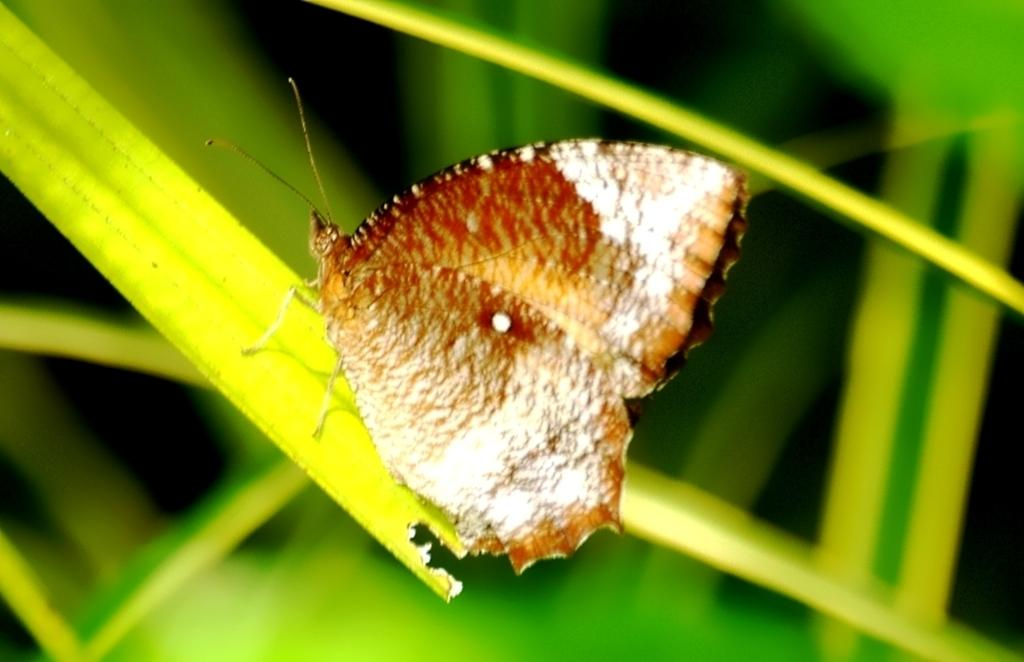What is the main subject of the image? There is a butterfly in the image. Where is the butterfly located? The butterfly is on a leaf. What else can be seen in the background of the image? There are more leaves visible in the background of the image. What type of toy is the butterfly playing with in the image? There is no toy present in the image; it features a butterfly on a leaf. 